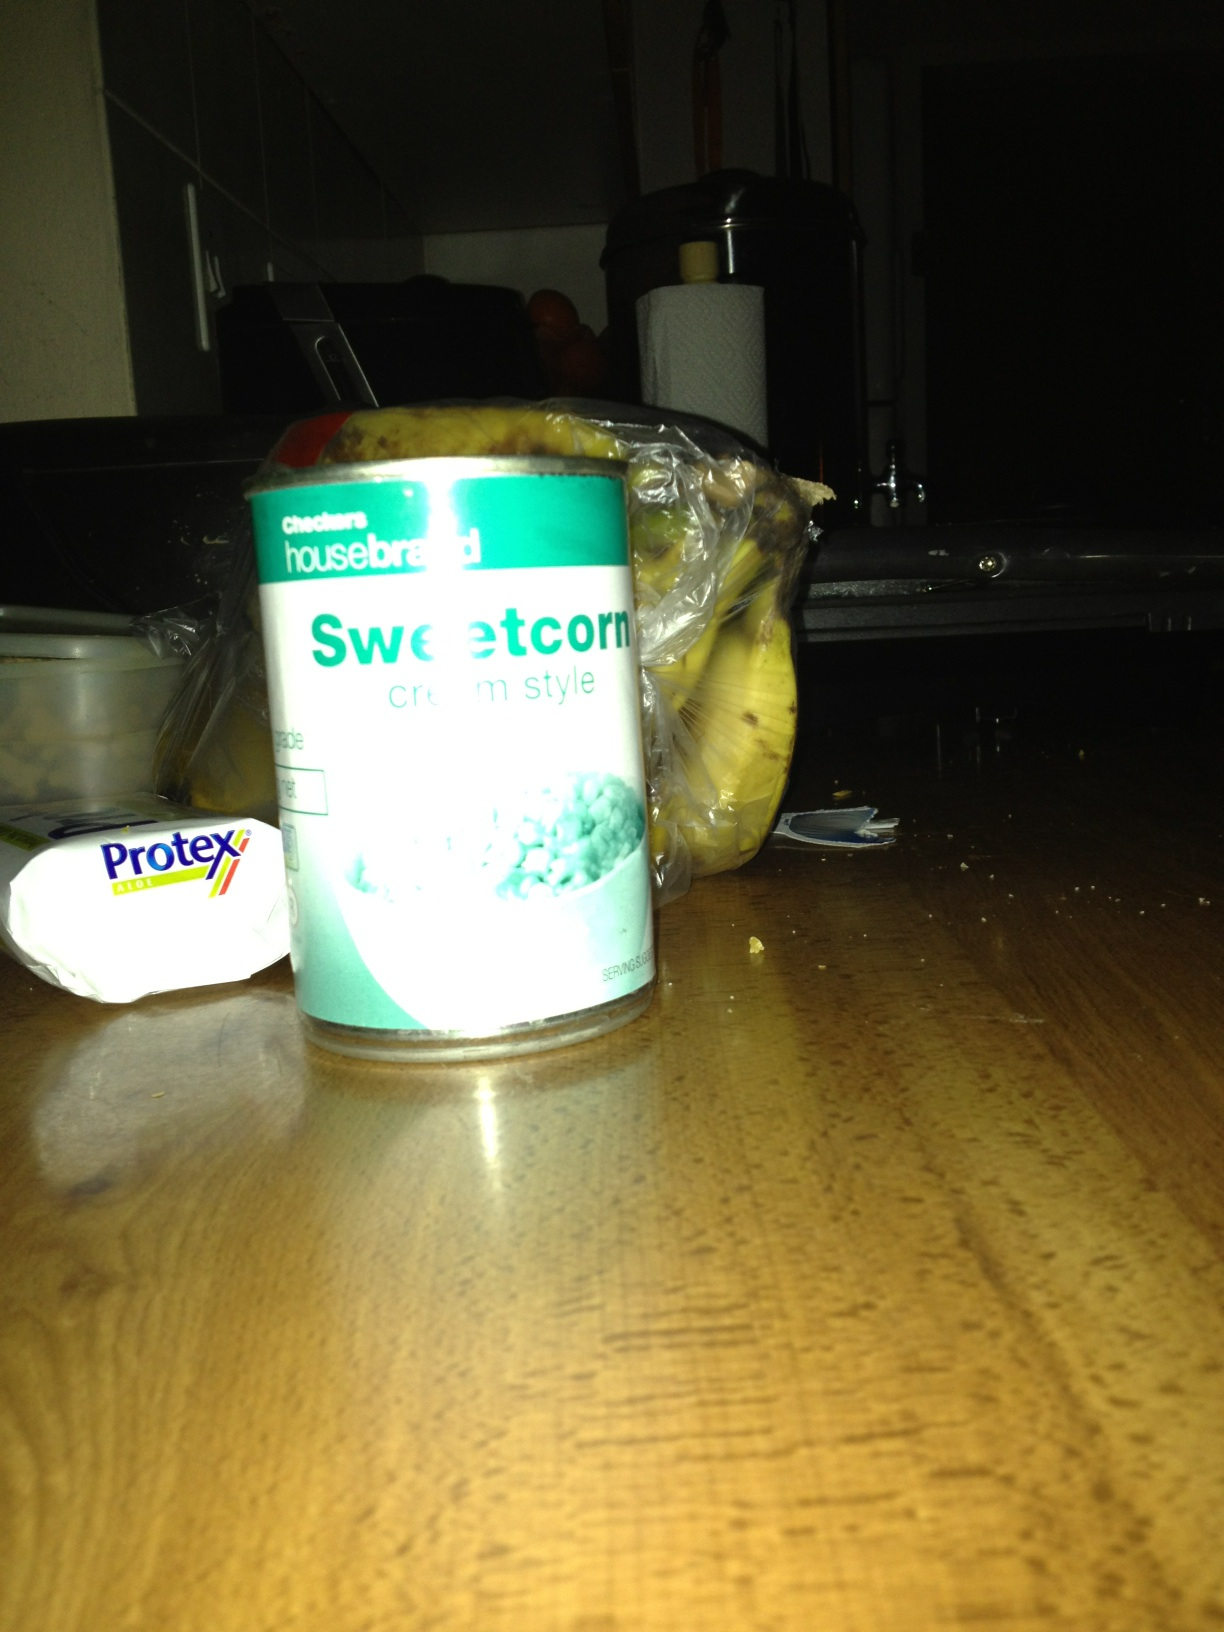Create a detailed recipe that includes the sweetcorn from the can. Sure! Here’s a recipe for Creamy Sweetcorn and Bacon Soup:

Ingredients:
- 2 cans of cream style sweetcorn
- 4 slices of bacon, chopped 
- 1 small onion, diced
- 2 cloves garlic, minced
- 1 medium potato, peeled and diced
- 4 cups chicken broth
- 1 cup heavy cream
- Salt and pepper to taste
- 2 tablespoons chopped fresh parsley

Instructions:
1. In a large pot, cook bacon over medium heat until crispy. Remove bacon and set aside, leaving drippings in the pot.
2. Add onion and garlic to the pot. Sauté until the onion is translucent.
3. Add the diced potato and cook for a few more minutes.
4. Pour in the chicken broth and bring to a boil. Reduce heat and simmer until potatoes are tender, about 10 minutes.
5. Stir in the cream style sweetcorn and heavy cream. Simmer for another 5-7 minutes.
6. Season with salt and pepper to taste.
7. Garnish with crispy bacon and chopped parsley before serving.
Enjoy your delicious and creamy sweetcorn and bacon soup! 